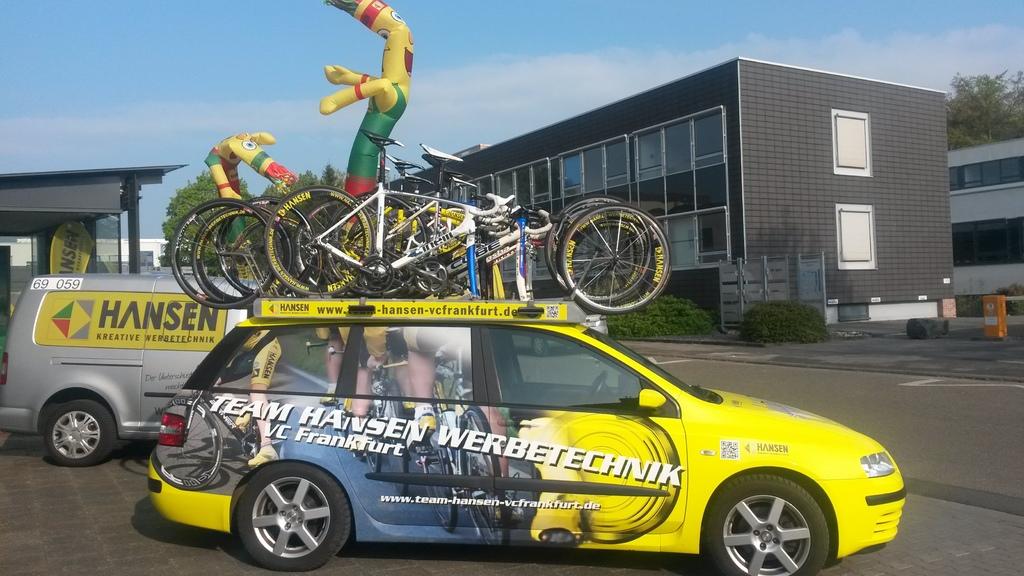Which company is the silver truck for?
Provide a short and direct response. Hansen. Is that a team hansen car?
Make the answer very short. Yes. 